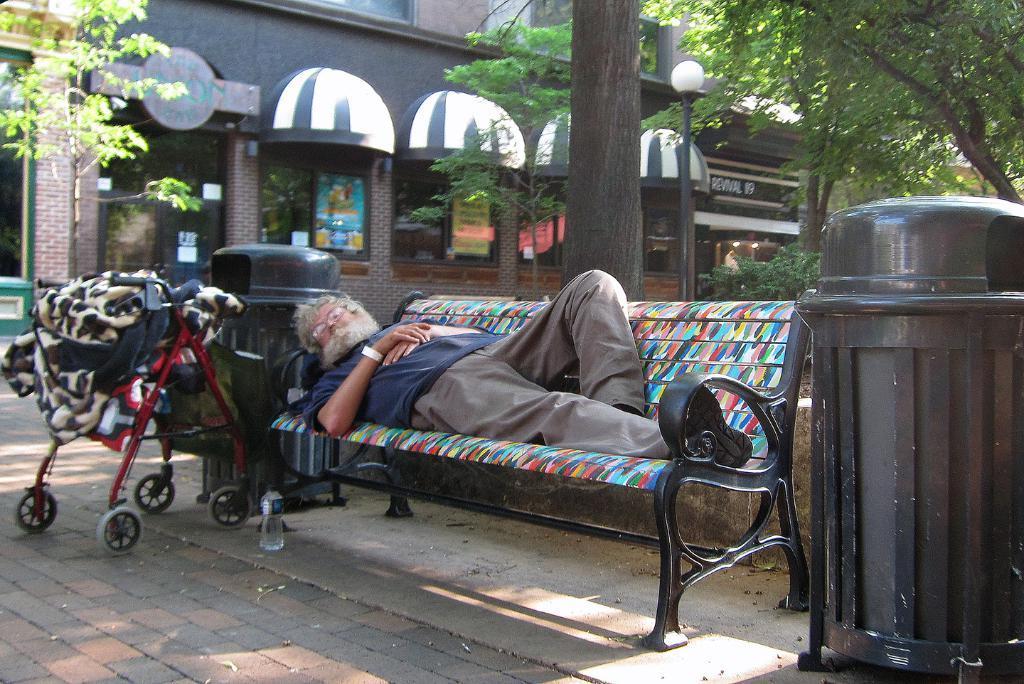In one or two sentences, can you explain what this image depicts? In the center of the image a man is lying on a bench. In the background of the image we can see garbage bins, trolley clothes, trees, stores, building, electric light pole, windows are there. At the bottom of the image we can see a bottle, ground are there. 